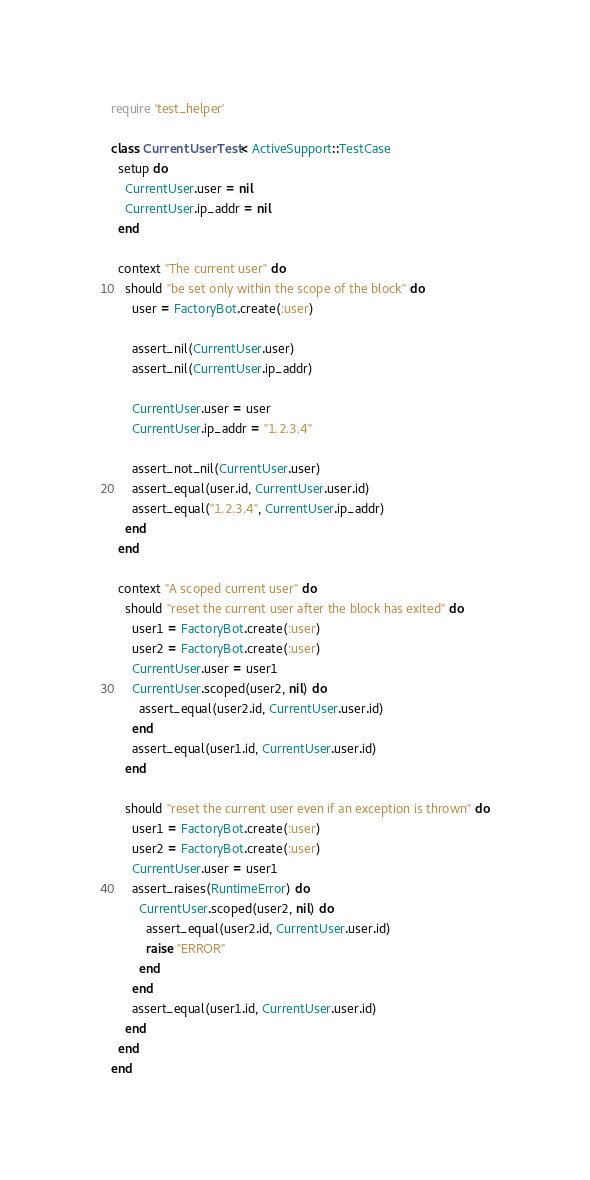Convert code to text. <code><loc_0><loc_0><loc_500><loc_500><_Ruby_>require 'test_helper'

class CurrentUserTest < ActiveSupport::TestCase
  setup do
    CurrentUser.user = nil
    CurrentUser.ip_addr = nil
  end
  
  context "The current user" do
    should "be set only within the scope of the block" do
      user = FactoryBot.create(:user)

      assert_nil(CurrentUser.user)
      assert_nil(CurrentUser.ip_addr)

      CurrentUser.user = user
      CurrentUser.ip_addr = "1.2.3.4"

      assert_not_nil(CurrentUser.user)
      assert_equal(user.id, CurrentUser.user.id)
      assert_equal("1.2.3.4", CurrentUser.ip_addr)
    end
  end

  context "A scoped current user" do
    should "reset the current user after the block has exited" do
      user1 = FactoryBot.create(:user)
      user2 = FactoryBot.create(:user)
      CurrentUser.user = user1
      CurrentUser.scoped(user2, nil) do
        assert_equal(user2.id, CurrentUser.user.id)
      end
      assert_equal(user1.id, CurrentUser.user.id)
    end

    should "reset the current user even if an exception is thrown" do
      user1 = FactoryBot.create(:user)
      user2 = FactoryBot.create(:user)
      CurrentUser.user = user1
      assert_raises(RuntimeError) do
        CurrentUser.scoped(user2, nil) do
          assert_equal(user2.id, CurrentUser.user.id)
          raise "ERROR"
        end
      end
      assert_equal(user1.id, CurrentUser.user.id)
    end
  end
end
</code> 